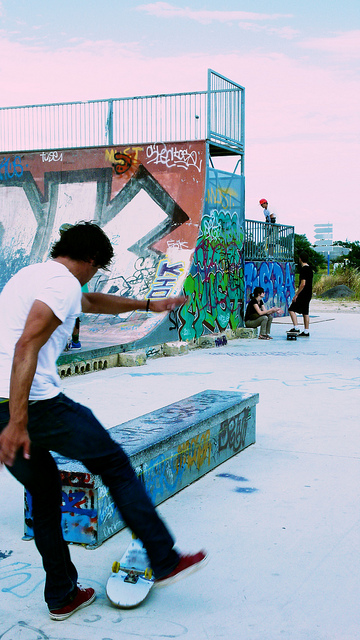What is the large ramp used for?
A. football
B. sledding
C. basketball
D. skateboarding
Answer with the option's letter from the given choices directly. D 